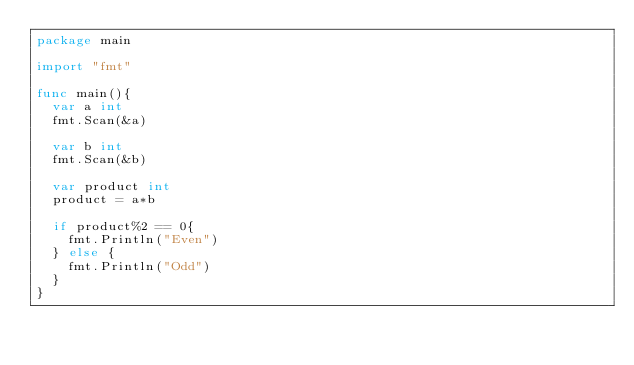<code> <loc_0><loc_0><loc_500><loc_500><_Go_>package main

import "fmt"

func main(){
	var a int
	fmt.Scan(&a)

	var b int
	fmt.Scan(&b)

	var product int
	product = a*b

	if product%2 == 0{
		fmt.Println("Even")
	} else {
		fmt.Println("Odd")
	}
}</code> 